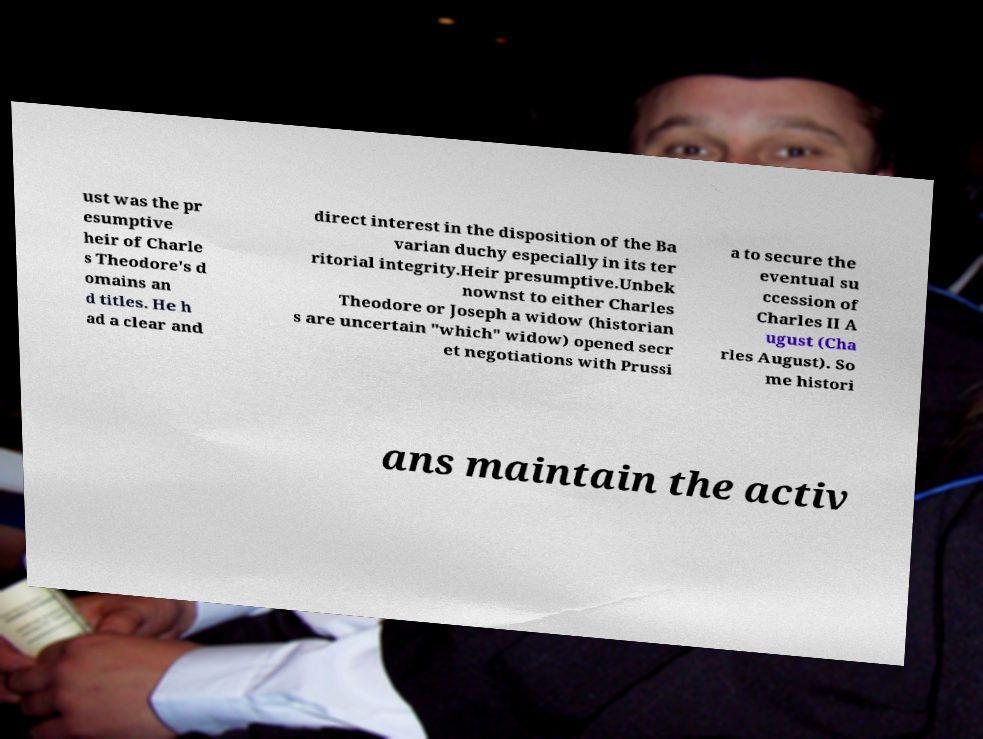I need the written content from this picture converted into text. Can you do that? ust was the pr esumptive heir of Charle s Theodore's d omains an d titles. He h ad a clear and direct interest in the disposition of the Ba varian duchy especially in its ter ritorial integrity.Heir presumptive.Unbek nownst to either Charles Theodore or Joseph a widow (historian s are uncertain "which" widow) opened secr et negotiations with Prussi a to secure the eventual su ccession of Charles II A ugust (Cha rles August). So me histori ans maintain the activ 